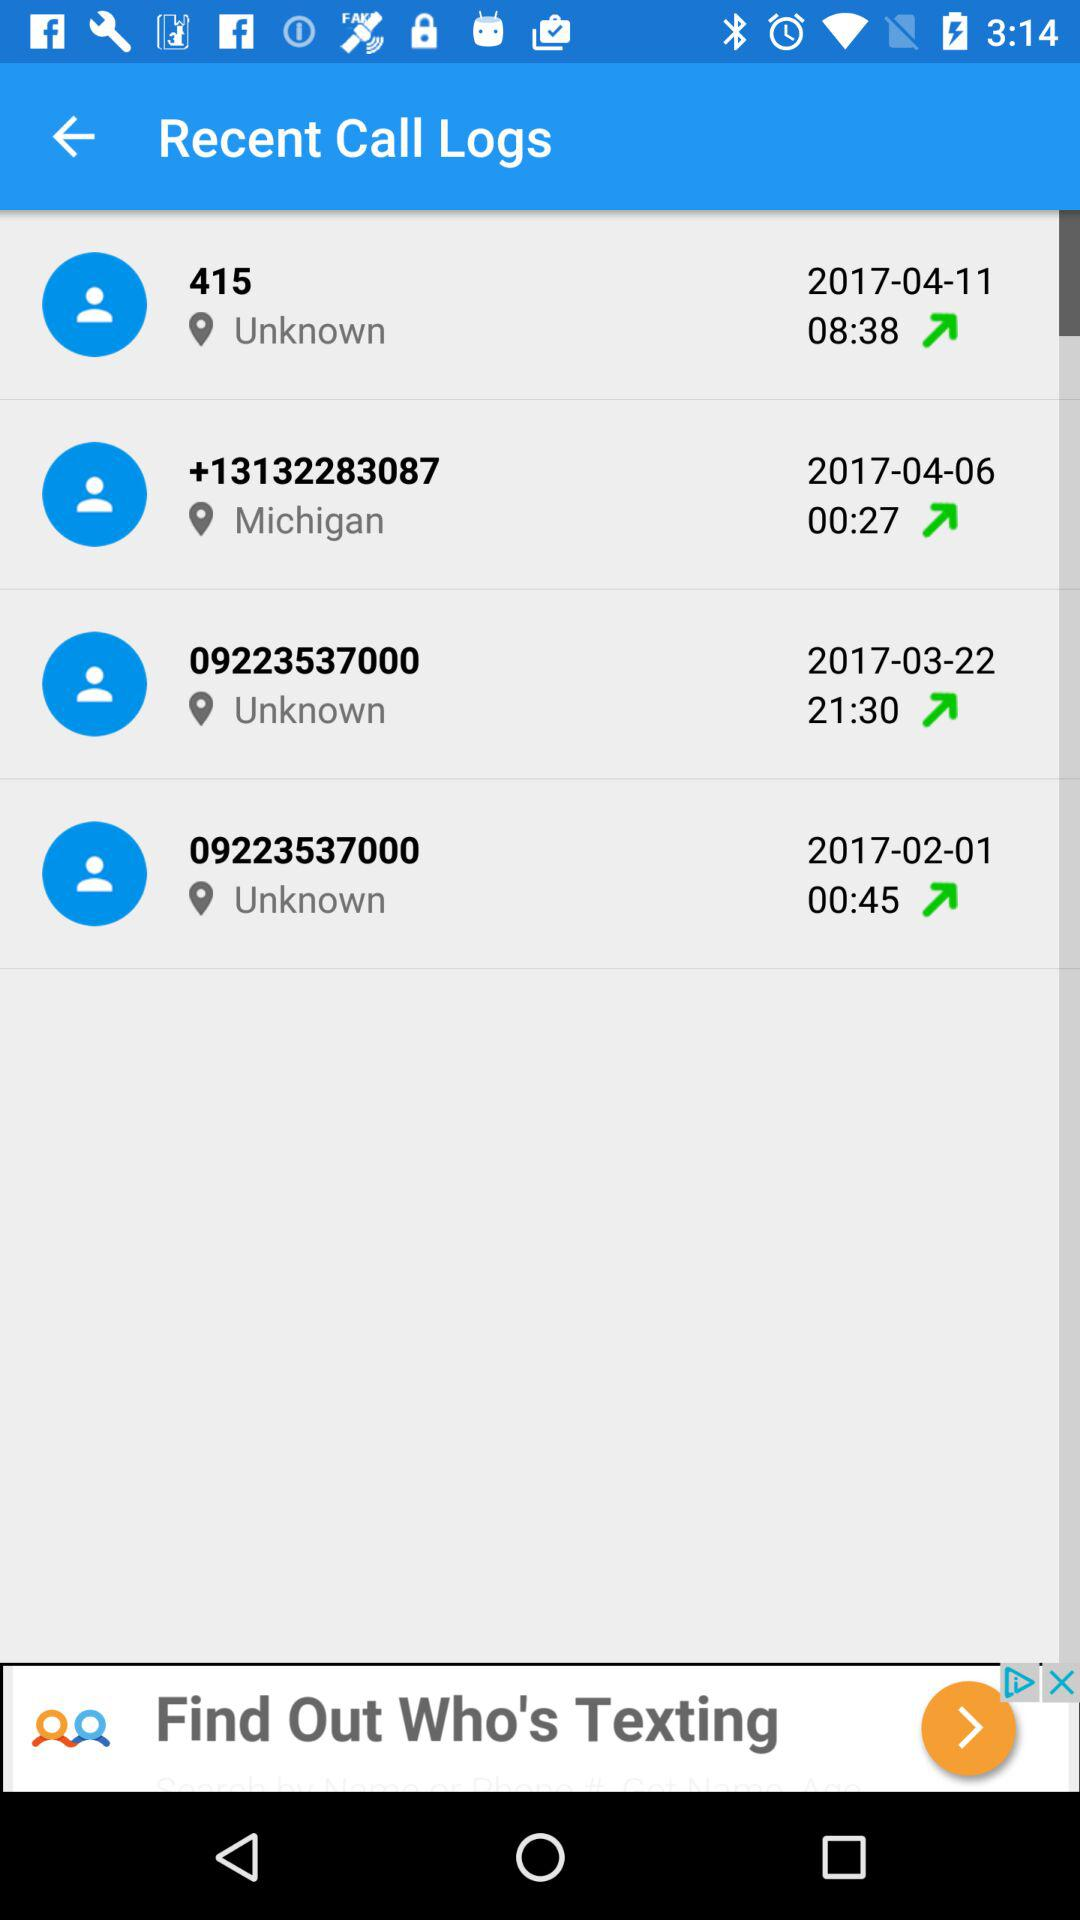What is the duration of the call with the number starting with 0922 on March 22, 2017? The duration of the call with the number starting with 0922 on March 22, 2017 is 21 minutes 30 seconds. 